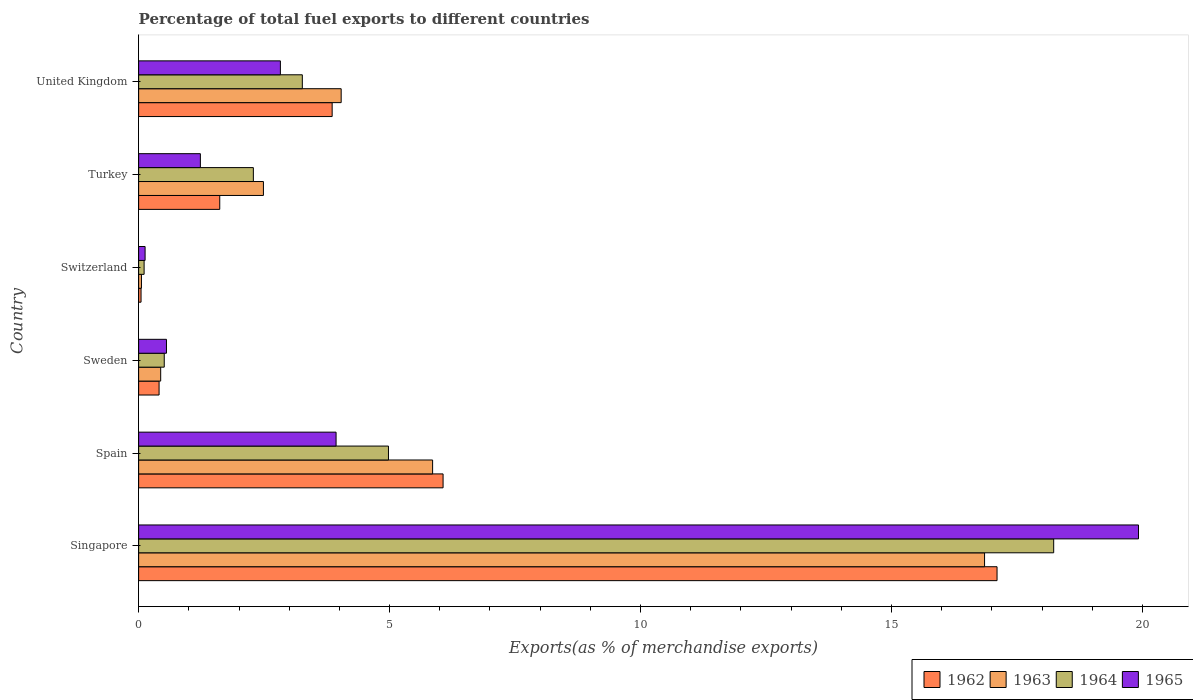Are the number of bars per tick equal to the number of legend labels?
Make the answer very short. Yes. How many bars are there on the 3rd tick from the top?
Make the answer very short. 4. What is the label of the 2nd group of bars from the top?
Give a very brief answer. Turkey. In how many cases, is the number of bars for a given country not equal to the number of legend labels?
Provide a short and direct response. 0. What is the percentage of exports to different countries in 1963 in Sweden?
Give a very brief answer. 0.44. Across all countries, what is the maximum percentage of exports to different countries in 1965?
Your response must be concise. 19.92. Across all countries, what is the minimum percentage of exports to different countries in 1962?
Provide a short and direct response. 0.05. In which country was the percentage of exports to different countries in 1963 maximum?
Make the answer very short. Singapore. In which country was the percentage of exports to different countries in 1965 minimum?
Keep it short and to the point. Switzerland. What is the total percentage of exports to different countries in 1965 in the graph?
Your answer should be very brief. 28.59. What is the difference between the percentage of exports to different countries in 1962 in Sweden and that in Turkey?
Your response must be concise. -1.21. What is the difference between the percentage of exports to different countries in 1965 in United Kingdom and the percentage of exports to different countries in 1964 in Spain?
Offer a terse response. -2.15. What is the average percentage of exports to different countries in 1964 per country?
Provide a succinct answer. 4.9. What is the difference between the percentage of exports to different countries in 1963 and percentage of exports to different countries in 1962 in Turkey?
Provide a short and direct response. 0.87. In how many countries, is the percentage of exports to different countries in 1962 greater than 12 %?
Your answer should be compact. 1. What is the ratio of the percentage of exports to different countries in 1965 in Spain to that in Sweden?
Your answer should be compact. 7.09. Is the difference between the percentage of exports to different countries in 1963 in Sweden and Switzerland greater than the difference between the percentage of exports to different countries in 1962 in Sweden and Switzerland?
Keep it short and to the point. Yes. What is the difference between the highest and the second highest percentage of exports to different countries in 1965?
Your response must be concise. 15.99. What is the difference between the highest and the lowest percentage of exports to different countries in 1962?
Offer a very short reply. 17.06. In how many countries, is the percentage of exports to different countries in 1965 greater than the average percentage of exports to different countries in 1965 taken over all countries?
Ensure brevity in your answer.  1. Is the sum of the percentage of exports to different countries in 1963 in Sweden and Turkey greater than the maximum percentage of exports to different countries in 1962 across all countries?
Offer a terse response. No. What does the 1st bar from the top in Switzerland represents?
Keep it short and to the point. 1965. What does the 1st bar from the bottom in United Kingdom represents?
Keep it short and to the point. 1962. Is it the case that in every country, the sum of the percentage of exports to different countries in 1965 and percentage of exports to different countries in 1962 is greater than the percentage of exports to different countries in 1964?
Give a very brief answer. Yes. How many bars are there?
Your response must be concise. 24. What is the difference between two consecutive major ticks on the X-axis?
Make the answer very short. 5. Are the values on the major ticks of X-axis written in scientific E-notation?
Give a very brief answer. No. Does the graph contain any zero values?
Make the answer very short. No. Where does the legend appear in the graph?
Make the answer very short. Bottom right. How are the legend labels stacked?
Provide a short and direct response. Horizontal. What is the title of the graph?
Ensure brevity in your answer.  Percentage of total fuel exports to different countries. Does "1978" appear as one of the legend labels in the graph?
Keep it short and to the point. No. What is the label or title of the X-axis?
Provide a short and direct response. Exports(as % of merchandise exports). What is the Exports(as % of merchandise exports) in 1962 in Singapore?
Ensure brevity in your answer.  17.1. What is the Exports(as % of merchandise exports) in 1963 in Singapore?
Give a very brief answer. 16.85. What is the Exports(as % of merchandise exports) in 1964 in Singapore?
Keep it short and to the point. 18.23. What is the Exports(as % of merchandise exports) of 1965 in Singapore?
Offer a terse response. 19.92. What is the Exports(as % of merchandise exports) of 1962 in Spain?
Provide a short and direct response. 6.07. What is the Exports(as % of merchandise exports) of 1963 in Spain?
Ensure brevity in your answer.  5.86. What is the Exports(as % of merchandise exports) of 1964 in Spain?
Provide a short and direct response. 4.98. What is the Exports(as % of merchandise exports) of 1965 in Spain?
Your response must be concise. 3.93. What is the Exports(as % of merchandise exports) in 1962 in Sweden?
Ensure brevity in your answer.  0.41. What is the Exports(as % of merchandise exports) of 1963 in Sweden?
Provide a succinct answer. 0.44. What is the Exports(as % of merchandise exports) in 1964 in Sweden?
Offer a very short reply. 0.51. What is the Exports(as % of merchandise exports) in 1965 in Sweden?
Your response must be concise. 0.55. What is the Exports(as % of merchandise exports) in 1962 in Switzerland?
Your response must be concise. 0.05. What is the Exports(as % of merchandise exports) in 1963 in Switzerland?
Provide a short and direct response. 0.06. What is the Exports(as % of merchandise exports) of 1964 in Switzerland?
Make the answer very short. 0.11. What is the Exports(as % of merchandise exports) of 1965 in Switzerland?
Make the answer very short. 0.13. What is the Exports(as % of merchandise exports) of 1962 in Turkey?
Your response must be concise. 1.62. What is the Exports(as % of merchandise exports) of 1963 in Turkey?
Your answer should be very brief. 2.49. What is the Exports(as % of merchandise exports) of 1964 in Turkey?
Provide a short and direct response. 2.29. What is the Exports(as % of merchandise exports) in 1965 in Turkey?
Ensure brevity in your answer.  1.23. What is the Exports(as % of merchandise exports) in 1962 in United Kingdom?
Keep it short and to the point. 3.86. What is the Exports(as % of merchandise exports) in 1963 in United Kingdom?
Provide a short and direct response. 4.04. What is the Exports(as % of merchandise exports) of 1964 in United Kingdom?
Your response must be concise. 3.26. What is the Exports(as % of merchandise exports) in 1965 in United Kingdom?
Your answer should be very brief. 2.82. Across all countries, what is the maximum Exports(as % of merchandise exports) of 1962?
Provide a short and direct response. 17.1. Across all countries, what is the maximum Exports(as % of merchandise exports) of 1963?
Offer a terse response. 16.85. Across all countries, what is the maximum Exports(as % of merchandise exports) in 1964?
Ensure brevity in your answer.  18.23. Across all countries, what is the maximum Exports(as % of merchandise exports) of 1965?
Make the answer very short. 19.92. Across all countries, what is the minimum Exports(as % of merchandise exports) of 1962?
Make the answer very short. 0.05. Across all countries, what is the minimum Exports(as % of merchandise exports) in 1963?
Give a very brief answer. 0.06. Across all countries, what is the minimum Exports(as % of merchandise exports) in 1964?
Your response must be concise. 0.11. Across all countries, what is the minimum Exports(as % of merchandise exports) of 1965?
Keep it short and to the point. 0.13. What is the total Exports(as % of merchandise exports) of 1962 in the graph?
Provide a short and direct response. 29.1. What is the total Exports(as % of merchandise exports) of 1963 in the graph?
Offer a very short reply. 29.73. What is the total Exports(as % of merchandise exports) of 1964 in the graph?
Ensure brevity in your answer.  29.38. What is the total Exports(as % of merchandise exports) in 1965 in the graph?
Provide a succinct answer. 28.59. What is the difference between the Exports(as % of merchandise exports) of 1962 in Singapore and that in Spain?
Your answer should be compact. 11.04. What is the difference between the Exports(as % of merchandise exports) of 1963 in Singapore and that in Spain?
Provide a short and direct response. 11. What is the difference between the Exports(as % of merchandise exports) in 1964 in Singapore and that in Spain?
Your response must be concise. 13.25. What is the difference between the Exports(as % of merchandise exports) in 1965 in Singapore and that in Spain?
Your answer should be very brief. 15.99. What is the difference between the Exports(as % of merchandise exports) in 1962 in Singapore and that in Sweden?
Give a very brief answer. 16.7. What is the difference between the Exports(as % of merchandise exports) in 1963 in Singapore and that in Sweden?
Make the answer very short. 16.42. What is the difference between the Exports(as % of merchandise exports) of 1964 in Singapore and that in Sweden?
Your response must be concise. 17.72. What is the difference between the Exports(as % of merchandise exports) in 1965 in Singapore and that in Sweden?
Make the answer very short. 19.37. What is the difference between the Exports(as % of merchandise exports) of 1962 in Singapore and that in Switzerland?
Offer a very short reply. 17.06. What is the difference between the Exports(as % of merchandise exports) in 1963 in Singapore and that in Switzerland?
Make the answer very short. 16.8. What is the difference between the Exports(as % of merchandise exports) of 1964 in Singapore and that in Switzerland?
Ensure brevity in your answer.  18.12. What is the difference between the Exports(as % of merchandise exports) in 1965 in Singapore and that in Switzerland?
Your response must be concise. 19.79. What is the difference between the Exports(as % of merchandise exports) in 1962 in Singapore and that in Turkey?
Your answer should be very brief. 15.49. What is the difference between the Exports(as % of merchandise exports) of 1963 in Singapore and that in Turkey?
Your answer should be compact. 14.37. What is the difference between the Exports(as % of merchandise exports) of 1964 in Singapore and that in Turkey?
Your response must be concise. 15.95. What is the difference between the Exports(as % of merchandise exports) in 1965 in Singapore and that in Turkey?
Give a very brief answer. 18.69. What is the difference between the Exports(as % of merchandise exports) in 1962 in Singapore and that in United Kingdom?
Your response must be concise. 13.25. What is the difference between the Exports(as % of merchandise exports) in 1963 in Singapore and that in United Kingdom?
Offer a very short reply. 12.82. What is the difference between the Exports(as % of merchandise exports) in 1964 in Singapore and that in United Kingdom?
Provide a succinct answer. 14.97. What is the difference between the Exports(as % of merchandise exports) of 1965 in Singapore and that in United Kingdom?
Keep it short and to the point. 17.1. What is the difference between the Exports(as % of merchandise exports) of 1962 in Spain and that in Sweden?
Offer a terse response. 5.66. What is the difference between the Exports(as % of merchandise exports) of 1963 in Spain and that in Sweden?
Make the answer very short. 5.42. What is the difference between the Exports(as % of merchandise exports) of 1964 in Spain and that in Sweden?
Provide a succinct answer. 4.47. What is the difference between the Exports(as % of merchandise exports) of 1965 in Spain and that in Sweden?
Make the answer very short. 3.38. What is the difference between the Exports(as % of merchandise exports) in 1962 in Spain and that in Switzerland?
Provide a short and direct response. 6.02. What is the difference between the Exports(as % of merchandise exports) of 1963 in Spain and that in Switzerland?
Offer a terse response. 5.8. What is the difference between the Exports(as % of merchandise exports) of 1964 in Spain and that in Switzerland?
Your answer should be compact. 4.87. What is the difference between the Exports(as % of merchandise exports) of 1965 in Spain and that in Switzerland?
Make the answer very short. 3.81. What is the difference between the Exports(as % of merchandise exports) in 1962 in Spain and that in Turkey?
Offer a very short reply. 4.45. What is the difference between the Exports(as % of merchandise exports) in 1963 in Spain and that in Turkey?
Give a very brief answer. 3.37. What is the difference between the Exports(as % of merchandise exports) in 1964 in Spain and that in Turkey?
Ensure brevity in your answer.  2.69. What is the difference between the Exports(as % of merchandise exports) in 1965 in Spain and that in Turkey?
Ensure brevity in your answer.  2.7. What is the difference between the Exports(as % of merchandise exports) in 1962 in Spain and that in United Kingdom?
Make the answer very short. 2.21. What is the difference between the Exports(as % of merchandise exports) of 1963 in Spain and that in United Kingdom?
Make the answer very short. 1.82. What is the difference between the Exports(as % of merchandise exports) in 1964 in Spain and that in United Kingdom?
Provide a short and direct response. 1.72. What is the difference between the Exports(as % of merchandise exports) in 1965 in Spain and that in United Kingdom?
Offer a terse response. 1.11. What is the difference between the Exports(as % of merchandise exports) in 1962 in Sweden and that in Switzerland?
Ensure brevity in your answer.  0.36. What is the difference between the Exports(as % of merchandise exports) in 1963 in Sweden and that in Switzerland?
Give a very brief answer. 0.38. What is the difference between the Exports(as % of merchandise exports) of 1964 in Sweden and that in Switzerland?
Offer a terse response. 0.4. What is the difference between the Exports(as % of merchandise exports) in 1965 in Sweden and that in Switzerland?
Give a very brief answer. 0.43. What is the difference between the Exports(as % of merchandise exports) of 1962 in Sweden and that in Turkey?
Ensure brevity in your answer.  -1.21. What is the difference between the Exports(as % of merchandise exports) of 1963 in Sweden and that in Turkey?
Offer a very short reply. -2.05. What is the difference between the Exports(as % of merchandise exports) in 1964 in Sweden and that in Turkey?
Give a very brief answer. -1.78. What is the difference between the Exports(as % of merchandise exports) of 1965 in Sweden and that in Turkey?
Provide a short and direct response. -0.68. What is the difference between the Exports(as % of merchandise exports) of 1962 in Sweden and that in United Kingdom?
Provide a short and direct response. -3.45. What is the difference between the Exports(as % of merchandise exports) in 1963 in Sweden and that in United Kingdom?
Provide a short and direct response. -3.6. What is the difference between the Exports(as % of merchandise exports) of 1964 in Sweden and that in United Kingdom?
Make the answer very short. -2.75. What is the difference between the Exports(as % of merchandise exports) in 1965 in Sweden and that in United Kingdom?
Give a very brief answer. -2.27. What is the difference between the Exports(as % of merchandise exports) in 1962 in Switzerland and that in Turkey?
Keep it short and to the point. -1.57. What is the difference between the Exports(as % of merchandise exports) of 1963 in Switzerland and that in Turkey?
Your response must be concise. -2.43. What is the difference between the Exports(as % of merchandise exports) of 1964 in Switzerland and that in Turkey?
Provide a succinct answer. -2.18. What is the difference between the Exports(as % of merchandise exports) of 1965 in Switzerland and that in Turkey?
Your answer should be very brief. -1.1. What is the difference between the Exports(as % of merchandise exports) in 1962 in Switzerland and that in United Kingdom?
Provide a short and direct response. -3.81. What is the difference between the Exports(as % of merchandise exports) in 1963 in Switzerland and that in United Kingdom?
Your answer should be very brief. -3.98. What is the difference between the Exports(as % of merchandise exports) in 1964 in Switzerland and that in United Kingdom?
Give a very brief answer. -3.15. What is the difference between the Exports(as % of merchandise exports) of 1965 in Switzerland and that in United Kingdom?
Provide a short and direct response. -2.7. What is the difference between the Exports(as % of merchandise exports) in 1962 in Turkey and that in United Kingdom?
Your response must be concise. -2.24. What is the difference between the Exports(as % of merchandise exports) in 1963 in Turkey and that in United Kingdom?
Your answer should be compact. -1.55. What is the difference between the Exports(as % of merchandise exports) of 1964 in Turkey and that in United Kingdom?
Give a very brief answer. -0.98. What is the difference between the Exports(as % of merchandise exports) of 1965 in Turkey and that in United Kingdom?
Ensure brevity in your answer.  -1.59. What is the difference between the Exports(as % of merchandise exports) in 1962 in Singapore and the Exports(as % of merchandise exports) in 1963 in Spain?
Your response must be concise. 11.25. What is the difference between the Exports(as % of merchandise exports) of 1962 in Singapore and the Exports(as % of merchandise exports) of 1964 in Spain?
Provide a short and direct response. 12.13. What is the difference between the Exports(as % of merchandise exports) in 1962 in Singapore and the Exports(as % of merchandise exports) in 1965 in Spain?
Your response must be concise. 13.17. What is the difference between the Exports(as % of merchandise exports) in 1963 in Singapore and the Exports(as % of merchandise exports) in 1964 in Spain?
Your answer should be very brief. 11.88. What is the difference between the Exports(as % of merchandise exports) in 1963 in Singapore and the Exports(as % of merchandise exports) in 1965 in Spain?
Offer a terse response. 12.92. What is the difference between the Exports(as % of merchandise exports) of 1964 in Singapore and the Exports(as % of merchandise exports) of 1965 in Spain?
Offer a terse response. 14.3. What is the difference between the Exports(as % of merchandise exports) in 1962 in Singapore and the Exports(as % of merchandise exports) in 1963 in Sweden?
Your answer should be compact. 16.66. What is the difference between the Exports(as % of merchandise exports) of 1962 in Singapore and the Exports(as % of merchandise exports) of 1964 in Sweden?
Keep it short and to the point. 16.59. What is the difference between the Exports(as % of merchandise exports) of 1962 in Singapore and the Exports(as % of merchandise exports) of 1965 in Sweden?
Make the answer very short. 16.55. What is the difference between the Exports(as % of merchandise exports) in 1963 in Singapore and the Exports(as % of merchandise exports) in 1964 in Sweden?
Make the answer very short. 16.34. What is the difference between the Exports(as % of merchandise exports) in 1963 in Singapore and the Exports(as % of merchandise exports) in 1965 in Sweden?
Your response must be concise. 16.3. What is the difference between the Exports(as % of merchandise exports) in 1964 in Singapore and the Exports(as % of merchandise exports) in 1965 in Sweden?
Your response must be concise. 17.68. What is the difference between the Exports(as % of merchandise exports) of 1962 in Singapore and the Exports(as % of merchandise exports) of 1963 in Switzerland?
Ensure brevity in your answer.  17.05. What is the difference between the Exports(as % of merchandise exports) of 1962 in Singapore and the Exports(as % of merchandise exports) of 1964 in Switzerland?
Offer a terse response. 16.99. What is the difference between the Exports(as % of merchandise exports) in 1962 in Singapore and the Exports(as % of merchandise exports) in 1965 in Switzerland?
Offer a very short reply. 16.97. What is the difference between the Exports(as % of merchandise exports) in 1963 in Singapore and the Exports(as % of merchandise exports) in 1964 in Switzerland?
Your response must be concise. 16.75. What is the difference between the Exports(as % of merchandise exports) in 1963 in Singapore and the Exports(as % of merchandise exports) in 1965 in Switzerland?
Ensure brevity in your answer.  16.73. What is the difference between the Exports(as % of merchandise exports) in 1964 in Singapore and the Exports(as % of merchandise exports) in 1965 in Switzerland?
Give a very brief answer. 18.1. What is the difference between the Exports(as % of merchandise exports) of 1962 in Singapore and the Exports(as % of merchandise exports) of 1963 in Turkey?
Give a very brief answer. 14.62. What is the difference between the Exports(as % of merchandise exports) in 1962 in Singapore and the Exports(as % of merchandise exports) in 1964 in Turkey?
Provide a succinct answer. 14.82. What is the difference between the Exports(as % of merchandise exports) of 1962 in Singapore and the Exports(as % of merchandise exports) of 1965 in Turkey?
Your response must be concise. 15.87. What is the difference between the Exports(as % of merchandise exports) of 1963 in Singapore and the Exports(as % of merchandise exports) of 1964 in Turkey?
Offer a very short reply. 14.57. What is the difference between the Exports(as % of merchandise exports) of 1963 in Singapore and the Exports(as % of merchandise exports) of 1965 in Turkey?
Provide a short and direct response. 15.62. What is the difference between the Exports(as % of merchandise exports) in 1964 in Singapore and the Exports(as % of merchandise exports) in 1965 in Turkey?
Provide a succinct answer. 17. What is the difference between the Exports(as % of merchandise exports) of 1962 in Singapore and the Exports(as % of merchandise exports) of 1963 in United Kingdom?
Make the answer very short. 13.07. What is the difference between the Exports(as % of merchandise exports) of 1962 in Singapore and the Exports(as % of merchandise exports) of 1964 in United Kingdom?
Your response must be concise. 13.84. What is the difference between the Exports(as % of merchandise exports) in 1962 in Singapore and the Exports(as % of merchandise exports) in 1965 in United Kingdom?
Your answer should be very brief. 14.28. What is the difference between the Exports(as % of merchandise exports) of 1963 in Singapore and the Exports(as % of merchandise exports) of 1964 in United Kingdom?
Offer a very short reply. 13.59. What is the difference between the Exports(as % of merchandise exports) in 1963 in Singapore and the Exports(as % of merchandise exports) in 1965 in United Kingdom?
Your answer should be compact. 14.03. What is the difference between the Exports(as % of merchandise exports) in 1964 in Singapore and the Exports(as % of merchandise exports) in 1965 in United Kingdom?
Your answer should be compact. 15.41. What is the difference between the Exports(as % of merchandise exports) of 1962 in Spain and the Exports(as % of merchandise exports) of 1963 in Sweden?
Give a very brief answer. 5.63. What is the difference between the Exports(as % of merchandise exports) in 1962 in Spain and the Exports(as % of merchandise exports) in 1964 in Sweden?
Your answer should be compact. 5.56. What is the difference between the Exports(as % of merchandise exports) of 1962 in Spain and the Exports(as % of merchandise exports) of 1965 in Sweden?
Give a very brief answer. 5.51. What is the difference between the Exports(as % of merchandise exports) in 1963 in Spain and the Exports(as % of merchandise exports) in 1964 in Sweden?
Your answer should be very brief. 5.35. What is the difference between the Exports(as % of merchandise exports) in 1963 in Spain and the Exports(as % of merchandise exports) in 1965 in Sweden?
Make the answer very short. 5.3. What is the difference between the Exports(as % of merchandise exports) in 1964 in Spain and the Exports(as % of merchandise exports) in 1965 in Sweden?
Provide a short and direct response. 4.42. What is the difference between the Exports(as % of merchandise exports) in 1962 in Spain and the Exports(as % of merchandise exports) in 1963 in Switzerland?
Offer a terse response. 6.01. What is the difference between the Exports(as % of merchandise exports) in 1962 in Spain and the Exports(as % of merchandise exports) in 1964 in Switzerland?
Make the answer very short. 5.96. What is the difference between the Exports(as % of merchandise exports) in 1962 in Spain and the Exports(as % of merchandise exports) in 1965 in Switzerland?
Provide a succinct answer. 5.94. What is the difference between the Exports(as % of merchandise exports) of 1963 in Spain and the Exports(as % of merchandise exports) of 1964 in Switzerland?
Offer a terse response. 5.75. What is the difference between the Exports(as % of merchandise exports) in 1963 in Spain and the Exports(as % of merchandise exports) in 1965 in Switzerland?
Your response must be concise. 5.73. What is the difference between the Exports(as % of merchandise exports) in 1964 in Spain and the Exports(as % of merchandise exports) in 1965 in Switzerland?
Offer a terse response. 4.85. What is the difference between the Exports(as % of merchandise exports) of 1962 in Spain and the Exports(as % of merchandise exports) of 1963 in Turkey?
Make the answer very short. 3.58. What is the difference between the Exports(as % of merchandise exports) in 1962 in Spain and the Exports(as % of merchandise exports) in 1964 in Turkey?
Keep it short and to the point. 3.78. What is the difference between the Exports(as % of merchandise exports) of 1962 in Spain and the Exports(as % of merchandise exports) of 1965 in Turkey?
Your response must be concise. 4.84. What is the difference between the Exports(as % of merchandise exports) in 1963 in Spain and the Exports(as % of merchandise exports) in 1964 in Turkey?
Give a very brief answer. 3.57. What is the difference between the Exports(as % of merchandise exports) of 1963 in Spain and the Exports(as % of merchandise exports) of 1965 in Turkey?
Your answer should be very brief. 4.63. What is the difference between the Exports(as % of merchandise exports) of 1964 in Spain and the Exports(as % of merchandise exports) of 1965 in Turkey?
Keep it short and to the point. 3.75. What is the difference between the Exports(as % of merchandise exports) of 1962 in Spain and the Exports(as % of merchandise exports) of 1963 in United Kingdom?
Offer a very short reply. 2.03. What is the difference between the Exports(as % of merchandise exports) of 1962 in Spain and the Exports(as % of merchandise exports) of 1964 in United Kingdom?
Offer a very short reply. 2.8. What is the difference between the Exports(as % of merchandise exports) in 1962 in Spain and the Exports(as % of merchandise exports) in 1965 in United Kingdom?
Make the answer very short. 3.24. What is the difference between the Exports(as % of merchandise exports) of 1963 in Spain and the Exports(as % of merchandise exports) of 1964 in United Kingdom?
Ensure brevity in your answer.  2.6. What is the difference between the Exports(as % of merchandise exports) of 1963 in Spain and the Exports(as % of merchandise exports) of 1965 in United Kingdom?
Offer a very short reply. 3.03. What is the difference between the Exports(as % of merchandise exports) of 1964 in Spain and the Exports(as % of merchandise exports) of 1965 in United Kingdom?
Make the answer very short. 2.15. What is the difference between the Exports(as % of merchandise exports) in 1962 in Sweden and the Exports(as % of merchandise exports) in 1963 in Switzerland?
Provide a succinct answer. 0.35. What is the difference between the Exports(as % of merchandise exports) in 1962 in Sweden and the Exports(as % of merchandise exports) in 1964 in Switzerland?
Keep it short and to the point. 0.3. What is the difference between the Exports(as % of merchandise exports) in 1962 in Sweden and the Exports(as % of merchandise exports) in 1965 in Switzerland?
Ensure brevity in your answer.  0.28. What is the difference between the Exports(as % of merchandise exports) in 1963 in Sweden and the Exports(as % of merchandise exports) in 1964 in Switzerland?
Your answer should be compact. 0.33. What is the difference between the Exports(as % of merchandise exports) of 1963 in Sweden and the Exports(as % of merchandise exports) of 1965 in Switzerland?
Your answer should be compact. 0.31. What is the difference between the Exports(as % of merchandise exports) in 1964 in Sweden and the Exports(as % of merchandise exports) in 1965 in Switzerland?
Give a very brief answer. 0.38. What is the difference between the Exports(as % of merchandise exports) of 1962 in Sweden and the Exports(as % of merchandise exports) of 1963 in Turkey?
Keep it short and to the point. -2.08. What is the difference between the Exports(as % of merchandise exports) in 1962 in Sweden and the Exports(as % of merchandise exports) in 1964 in Turkey?
Offer a terse response. -1.88. What is the difference between the Exports(as % of merchandise exports) in 1962 in Sweden and the Exports(as % of merchandise exports) in 1965 in Turkey?
Offer a terse response. -0.82. What is the difference between the Exports(as % of merchandise exports) of 1963 in Sweden and the Exports(as % of merchandise exports) of 1964 in Turkey?
Provide a short and direct response. -1.85. What is the difference between the Exports(as % of merchandise exports) of 1963 in Sweden and the Exports(as % of merchandise exports) of 1965 in Turkey?
Your response must be concise. -0.79. What is the difference between the Exports(as % of merchandise exports) of 1964 in Sweden and the Exports(as % of merchandise exports) of 1965 in Turkey?
Give a very brief answer. -0.72. What is the difference between the Exports(as % of merchandise exports) in 1962 in Sweden and the Exports(as % of merchandise exports) in 1963 in United Kingdom?
Your answer should be very brief. -3.63. What is the difference between the Exports(as % of merchandise exports) of 1962 in Sweden and the Exports(as % of merchandise exports) of 1964 in United Kingdom?
Make the answer very short. -2.85. What is the difference between the Exports(as % of merchandise exports) of 1962 in Sweden and the Exports(as % of merchandise exports) of 1965 in United Kingdom?
Make the answer very short. -2.42. What is the difference between the Exports(as % of merchandise exports) of 1963 in Sweden and the Exports(as % of merchandise exports) of 1964 in United Kingdom?
Make the answer very short. -2.82. What is the difference between the Exports(as % of merchandise exports) of 1963 in Sweden and the Exports(as % of merchandise exports) of 1965 in United Kingdom?
Your answer should be compact. -2.38. What is the difference between the Exports(as % of merchandise exports) of 1964 in Sweden and the Exports(as % of merchandise exports) of 1965 in United Kingdom?
Keep it short and to the point. -2.31. What is the difference between the Exports(as % of merchandise exports) of 1962 in Switzerland and the Exports(as % of merchandise exports) of 1963 in Turkey?
Ensure brevity in your answer.  -2.44. What is the difference between the Exports(as % of merchandise exports) of 1962 in Switzerland and the Exports(as % of merchandise exports) of 1964 in Turkey?
Give a very brief answer. -2.24. What is the difference between the Exports(as % of merchandise exports) of 1962 in Switzerland and the Exports(as % of merchandise exports) of 1965 in Turkey?
Your answer should be compact. -1.18. What is the difference between the Exports(as % of merchandise exports) in 1963 in Switzerland and the Exports(as % of merchandise exports) in 1964 in Turkey?
Provide a short and direct response. -2.23. What is the difference between the Exports(as % of merchandise exports) of 1963 in Switzerland and the Exports(as % of merchandise exports) of 1965 in Turkey?
Ensure brevity in your answer.  -1.17. What is the difference between the Exports(as % of merchandise exports) in 1964 in Switzerland and the Exports(as % of merchandise exports) in 1965 in Turkey?
Make the answer very short. -1.12. What is the difference between the Exports(as % of merchandise exports) in 1962 in Switzerland and the Exports(as % of merchandise exports) in 1963 in United Kingdom?
Offer a very short reply. -3.99. What is the difference between the Exports(as % of merchandise exports) of 1962 in Switzerland and the Exports(as % of merchandise exports) of 1964 in United Kingdom?
Make the answer very short. -3.21. What is the difference between the Exports(as % of merchandise exports) in 1962 in Switzerland and the Exports(as % of merchandise exports) in 1965 in United Kingdom?
Provide a succinct answer. -2.78. What is the difference between the Exports(as % of merchandise exports) in 1963 in Switzerland and the Exports(as % of merchandise exports) in 1964 in United Kingdom?
Your answer should be very brief. -3.21. What is the difference between the Exports(as % of merchandise exports) in 1963 in Switzerland and the Exports(as % of merchandise exports) in 1965 in United Kingdom?
Provide a succinct answer. -2.77. What is the difference between the Exports(as % of merchandise exports) in 1964 in Switzerland and the Exports(as % of merchandise exports) in 1965 in United Kingdom?
Provide a short and direct response. -2.72. What is the difference between the Exports(as % of merchandise exports) in 1962 in Turkey and the Exports(as % of merchandise exports) in 1963 in United Kingdom?
Provide a succinct answer. -2.42. What is the difference between the Exports(as % of merchandise exports) of 1962 in Turkey and the Exports(as % of merchandise exports) of 1964 in United Kingdom?
Ensure brevity in your answer.  -1.65. What is the difference between the Exports(as % of merchandise exports) in 1962 in Turkey and the Exports(as % of merchandise exports) in 1965 in United Kingdom?
Offer a very short reply. -1.21. What is the difference between the Exports(as % of merchandise exports) of 1963 in Turkey and the Exports(as % of merchandise exports) of 1964 in United Kingdom?
Give a very brief answer. -0.78. What is the difference between the Exports(as % of merchandise exports) of 1963 in Turkey and the Exports(as % of merchandise exports) of 1965 in United Kingdom?
Offer a very short reply. -0.34. What is the difference between the Exports(as % of merchandise exports) of 1964 in Turkey and the Exports(as % of merchandise exports) of 1965 in United Kingdom?
Make the answer very short. -0.54. What is the average Exports(as % of merchandise exports) in 1962 per country?
Provide a short and direct response. 4.85. What is the average Exports(as % of merchandise exports) of 1963 per country?
Make the answer very short. 4.96. What is the average Exports(as % of merchandise exports) in 1964 per country?
Provide a short and direct response. 4.9. What is the average Exports(as % of merchandise exports) of 1965 per country?
Your answer should be compact. 4.77. What is the difference between the Exports(as % of merchandise exports) in 1962 and Exports(as % of merchandise exports) in 1963 in Singapore?
Offer a very short reply. 0.25. What is the difference between the Exports(as % of merchandise exports) of 1962 and Exports(as % of merchandise exports) of 1964 in Singapore?
Give a very brief answer. -1.13. What is the difference between the Exports(as % of merchandise exports) of 1962 and Exports(as % of merchandise exports) of 1965 in Singapore?
Offer a very short reply. -2.82. What is the difference between the Exports(as % of merchandise exports) in 1963 and Exports(as % of merchandise exports) in 1964 in Singapore?
Offer a very short reply. -1.38. What is the difference between the Exports(as % of merchandise exports) of 1963 and Exports(as % of merchandise exports) of 1965 in Singapore?
Give a very brief answer. -3.07. What is the difference between the Exports(as % of merchandise exports) of 1964 and Exports(as % of merchandise exports) of 1965 in Singapore?
Make the answer very short. -1.69. What is the difference between the Exports(as % of merchandise exports) of 1962 and Exports(as % of merchandise exports) of 1963 in Spain?
Your answer should be compact. 0.21. What is the difference between the Exports(as % of merchandise exports) in 1962 and Exports(as % of merchandise exports) in 1964 in Spain?
Offer a terse response. 1.09. What is the difference between the Exports(as % of merchandise exports) of 1962 and Exports(as % of merchandise exports) of 1965 in Spain?
Your answer should be compact. 2.13. What is the difference between the Exports(as % of merchandise exports) of 1963 and Exports(as % of merchandise exports) of 1964 in Spain?
Keep it short and to the point. 0.88. What is the difference between the Exports(as % of merchandise exports) of 1963 and Exports(as % of merchandise exports) of 1965 in Spain?
Ensure brevity in your answer.  1.92. What is the difference between the Exports(as % of merchandise exports) in 1964 and Exports(as % of merchandise exports) in 1965 in Spain?
Give a very brief answer. 1.04. What is the difference between the Exports(as % of merchandise exports) in 1962 and Exports(as % of merchandise exports) in 1963 in Sweden?
Ensure brevity in your answer.  -0.03. What is the difference between the Exports(as % of merchandise exports) of 1962 and Exports(as % of merchandise exports) of 1964 in Sweden?
Keep it short and to the point. -0.1. What is the difference between the Exports(as % of merchandise exports) of 1962 and Exports(as % of merchandise exports) of 1965 in Sweden?
Make the answer very short. -0.15. What is the difference between the Exports(as % of merchandise exports) in 1963 and Exports(as % of merchandise exports) in 1964 in Sweden?
Keep it short and to the point. -0.07. What is the difference between the Exports(as % of merchandise exports) of 1963 and Exports(as % of merchandise exports) of 1965 in Sweden?
Your response must be concise. -0.12. What is the difference between the Exports(as % of merchandise exports) of 1964 and Exports(as % of merchandise exports) of 1965 in Sweden?
Provide a short and direct response. -0.04. What is the difference between the Exports(as % of merchandise exports) in 1962 and Exports(as % of merchandise exports) in 1963 in Switzerland?
Offer a very short reply. -0.01. What is the difference between the Exports(as % of merchandise exports) in 1962 and Exports(as % of merchandise exports) in 1964 in Switzerland?
Your answer should be compact. -0.06. What is the difference between the Exports(as % of merchandise exports) in 1962 and Exports(as % of merchandise exports) in 1965 in Switzerland?
Your response must be concise. -0.08. What is the difference between the Exports(as % of merchandise exports) in 1963 and Exports(as % of merchandise exports) in 1964 in Switzerland?
Offer a terse response. -0.05. What is the difference between the Exports(as % of merchandise exports) of 1963 and Exports(as % of merchandise exports) of 1965 in Switzerland?
Offer a very short reply. -0.07. What is the difference between the Exports(as % of merchandise exports) of 1964 and Exports(as % of merchandise exports) of 1965 in Switzerland?
Your answer should be very brief. -0.02. What is the difference between the Exports(as % of merchandise exports) of 1962 and Exports(as % of merchandise exports) of 1963 in Turkey?
Offer a terse response. -0.87. What is the difference between the Exports(as % of merchandise exports) of 1962 and Exports(as % of merchandise exports) of 1964 in Turkey?
Provide a short and direct response. -0.67. What is the difference between the Exports(as % of merchandise exports) of 1962 and Exports(as % of merchandise exports) of 1965 in Turkey?
Your answer should be very brief. 0.39. What is the difference between the Exports(as % of merchandise exports) in 1963 and Exports(as % of merchandise exports) in 1964 in Turkey?
Your answer should be compact. 0.2. What is the difference between the Exports(as % of merchandise exports) in 1963 and Exports(as % of merchandise exports) in 1965 in Turkey?
Your answer should be compact. 1.26. What is the difference between the Exports(as % of merchandise exports) of 1964 and Exports(as % of merchandise exports) of 1965 in Turkey?
Ensure brevity in your answer.  1.06. What is the difference between the Exports(as % of merchandise exports) in 1962 and Exports(as % of merchandise exports) in 1963 in United Kingdom?
Give a very brief answer. -0.18. What is the difference between the Exports(as % of merchandise exports) of 1962 and Exports(as % of merchandise exports) of 1964 in United Kingdom?
Provide a short and direct response. 0.59. What is the difference between the Exports(as % of merchandise exports) in 1962 and Exports(as % of merchandise exports) in 1965 in United Kingdom?
Provide a succinct answer. 1.03. What is the difference between the Exports(as % of merchandise exports) in 1963 and Exports(as % of merchandise exports) in 1964 in United Kingdom?
Ensure brevity in your answer.  0.77. What is the difference between the Exports(as % of merchandise exports) of 1963 and Exports(as % of merchandise exports) of 1965 in United Kingdom?
Provide a short and direct response. 1.21. What is the difference between the Exports(as % of merchandise exports) in 1964 and Exports(as % of merchandise exports) in 1965 in United Kingdom?
Your response must be concise. 0.44. What is the ratio of the Exports(as % of merchandise exports) in 1962 in Singapore to that in Spain?
Provide a succinct answer. 2.82. What is the ratio of the Exports(as % of merchandise exports) in 1963 in Singapore to that in Spain?
Keep it short and to the point. 2.88. What is the ratio of the Exports(as % of merchandise exports) of 1964 in Singapore to that in Spain?
Provide a succinct answer. 3.66. What is the ratio of the Exports(as % of merchandise exports) of 1965 in Singapore to that in Spain?
Keep it short and to the point. 5.06. What is the ratio of the Exports(as % of merchandise exports) in 1962 in Singapore to that in Sweden?
Offer a terse response. 41.99. What is the ratio of the Exports(as % of merchandise exports) of 1963 in Singapore to that in Sweden?
Your answer should be compact. 38.35. What is the ratio of the Exports(as % of merchandise exports) of 1964 in Singapore to that in Sweden?
Your response must be concise. 35.72. What is the ratio of the Exports(as % of merchandise exports) of 1965 in Singapore to that in Sweden?
Offer a terse response. 35.92. What is the ratio of the Exports(as % of merchandise exports) of 1962 in Singapore to that in Switzerland?
Your answer should be very brief. 354.54. What is the ratio of the Exports(as % of merchandise exports) in 1963 in Singapore to that in Switzerland?
Give a very brief answer. 299.62. What is the ratio of the Exports(as % of merchandise exports) in 1964 in Singapore to that in Switzerland?
Ensure brevity in your answer.  167.06. What is the ratio of the Exports(as % of merchandise exports) of 1965 in Singapore to that in Switzerland?
Your response must be concise. 154.67. What is the ratio of the Exports(as % of merchandise exports) of 1962 in Singapore to that in Turkey?
Offer a very short reply. 10.58. What is the ratio of the Exports(as % of merchandise exports) in 1963 in Singapore to that in Turkey?
Provide a short and direct response. 6.78. What is the ratio of the Exports(as % of merchandise exports) in 1964 in Singapore to that in Turkey?
Keep it short and to the point. 7.98. What is the ratio of the Exports(as % of merchandise exports) in 1965 in Singapore to that in Turkey?
Your response must be concise. 16.19. What is the ratio of the Exports(as % of merchandise exports) in 1962 in Singapore to that in United Kingdom?
Keep it short and to the point. 4.44. What is the ratio of the Exports(as % of merchandise exports) of 1963 in Singapore to that in United Kingdom?
Make the answer very short. 4.18. What is the ratio of the Exports(as % of merchandise exports) of 1964 in Singapore to that in United Kingdom?
Ensure brevity in your answer.  5.59. What is the ratio of the Exports(as % of merchandise exports) in 1965 in Singapore to that in United Kingdom?
Offer a terse response. 7.05. What is the ratio of the Exports(as % of merchandise exports) in 1962 in Spain to that in Sweden?
Provide a short and direct response. 14.89. What is the ratio of the Exports(as % of merchandise exports) of 1963 in Spain to that in Sweden?
Provide a succinct answer. 13.33. What is the ratio of the Exports(as % of merchandise exports) of 1964 in Spain to that in Sweden?
Give a very brief answer. 9.75. What is the ratio of the Exports(as % of merchandise exports) in 1965 in Spain to that in Sweden?
Your answer should be very brief. 7.09. What is the ratio of the Exports(as % of merchandise exports) in 1962 in Spain to that in Switzerland?
Give a very brief answer. 125.74. What is the ratio of the Exports(as % of merchandise exports) in 1963 in Spain to that in Switzerland?
Your answer should be very brief. 104.12. What is the ratio of the Exports(as % of merchandise exports) of 1964 in Spain to that in Switzerland?
Offer a very short reply. 45.62. What is the ratio of the Exports(as % of merchandise exports) in 1965 in Spain to that in Switzerland?
Your response must be concise. 30.54. What is the ratio of the Exports(as % of merchandise exports) in 1962 in Spain to that in Turkey?
Your response must be concise. 3.75. What is the ratio of the Exports(as % of merchandise exports) in 1963 in Spain to that in Turkey?
Keep it short and to the point. 2.36. What is the ratio of the Exports(as % of merchandise exports) in 1964 in Spain to that in Turkey?
Your answer should be compact. 2.18. What is the ratio of the Exports(as % of merchandise exports) of 1965 in Spain to that in Turkey?
Your response must be concise. 3.2. What is the ratio of the Exports(as % of merchandise exports) of 1962 in Spain to that in United Kingdom?
Offer a terse response. 1.57. What is the ratio of the Exports(as % of merchandise exports) in 1963 in Spain to that in United Kingdom?
Ensure brevity in your answer.  1.45. What is the ratio of the Exports(as % of merchandise exports) of 1964 in Spain to that in United Kingdom?
Give a very brief answer. 1.53. What is the ratio of the Exports(as % of merchandise exports) of 1965 in Spain to that in United Kingdom?
Keep it short and to the point. 1.39. What is the ratio of the Exports(as % of merchandise exports) in 1962 in Sweden to that in Switzerland?
Offer a very short reply. 8.44. What is the ratio of the Exports(as % of merchandise exports) in 1963 in Sweden to that in Switzerland?
Provide a succinct answer. 7.81. What is the ratio of the Exports(as % of merchandise exports) in 1964 in Sweden to that in Switzerland?
Keep it short and to the point. 4.68. What is the ratio of the Exports(as % of merchandise exports) of 1965 in Sweden to that in Switzerland?
Your answer should be very brief. 4.31. What is the ratio of the Exports(as % of merchandise exports) of 1962 in Sweden to that in Turkey?
Your answer should be compact. 0.25. What is the ratio of the Exports(as % of merchandise exports) of 1963 in Sweden to that in Turkey?
Your response must be concise. 0.18. What is the ratio of the Exports(as % of merchandise exports) of 1964 in Sweden to that in Turkey?
Offer a very short reply. 0.22. What is the ratio of the Exports(as % of merchandise exports) of 1965 in Sweden to that in Turkey?
Ensure brevity in your answer.  0.45. What is the ratio of the Exports(as % of merchandise exports) of 1962 in Sweden to that in United Kingdom?
Keep it short and to the point. 0.11. What is the ratio of the Exports(as % of merchandise exports) in 1963 in Sweden to that in United Kingdom?
Your answer should be very brief. 0.11. What is the ratio of the Exports(as % of merchandise exports) in 1964 in Sweden to that in United Kingdom?
Make the answer very short. 0.16. What is the ratio of the Exports(as % of merchandise exports) in 1965 in Sweden to that in United Kingdom?
Provide a short and direct response. 0.2. What is the ratio of the Exports(as % of merchandise exports) in 1962 in Switzerland to that in Turkey?
Give a very brief answer. 0.03. What is the ratio of the Exports(as % of merchandise exports) of 1963 in Switzerland to that in Turkey?
Give a very brief answer. 0.02. What is the ratio of the Exports(as % of merchandise exports) of 1964 in Switzerland to that in Turkey?
Keep it short and to the point. 0.05. What is the ratio of the Exports(as % of merchandise exports) in 1965 in Switzerland to that in Turkey?
Your answer should be very brief. 0.1. What is the ratio of the Exports(as % of merchandise exports) in 1962 in Switzerland to that in United Kingdom?
Your answer should be very brief. 0.01. What is the ratio of the Exports(as % of merchandise exports) of 1963 in Switzerland to that in United Kingdom?
Make the answer very short. 0.01. What is the ratio of the Exports(as % of merchandise exports) of 1964 in Switzerland to that in United Kingdom?
Offer a terse response. 0.03. What is the ratio of the Exports(as % of merchandise exports) in 1965 in Switzerland to that in United Kingdom?
Make the answer very short. 0.05. What is the ratio of the Exports(as % of merchandise exports) in 1962 in Turkey to that in United Kingdom?
Keep it short and to the point. 0.42. What is the ratio of the Exports(as % of merchandise exports) in 1963 in Turkey to that in United Kingdom?
Your response must be concise. 0.62. What is the ratio of the Exports(as % of merchandise exports) in 1964 in Turkey to that in United Kingdom?
Your response must be concise. 0.7. What is the ratio of the Exports(as % of merchandise exports) of 1965 in Turkey to that in United Kingdom?
Offer a terse response. 0.44. What is the difference between the highest and the second highest Exports(as % of merchandise exports) in 1962?
Offer a very short reply. 11.04. What is the difference between the highest and the second highest Exports(as % of merchandise exports) in 1963?
Offer a very short reply. 11. What is the difference between the highest and the second highest Exports(as % of merchandise exports) of 1964?
Give a very brief answer. 13.25. What is the difference between the highest and the second highest Exports(as % of merchandise exports) in 1965?
Keep it short and to the point. 15.99. What is the difference between the highest and the lowest Exports(as % of merchandise exports) of 1962?
Your answer should be very brief. 17.06. What is the difference between the highest and the lowest Exports(as % of merchandise exports) in 1963?
Offer a very short reply. 16.8. What is the difference between the highest and the lowest Exports(as % of merchandise exports) in 1964?
Offer a terse response. 18.12. What is the difference between the highest and the lowest Exports(as % of merchandise exports) of 1965?
Keep it short and to the point. 19.79. 